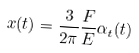Convert formula to latex. <formula><loc_0><loc_0><loc_500><loc_500>x ( t ) = \frac { 3 } { 2 \pi } \frac { F } { E } \alpha _ { t } ( t )</formula> 